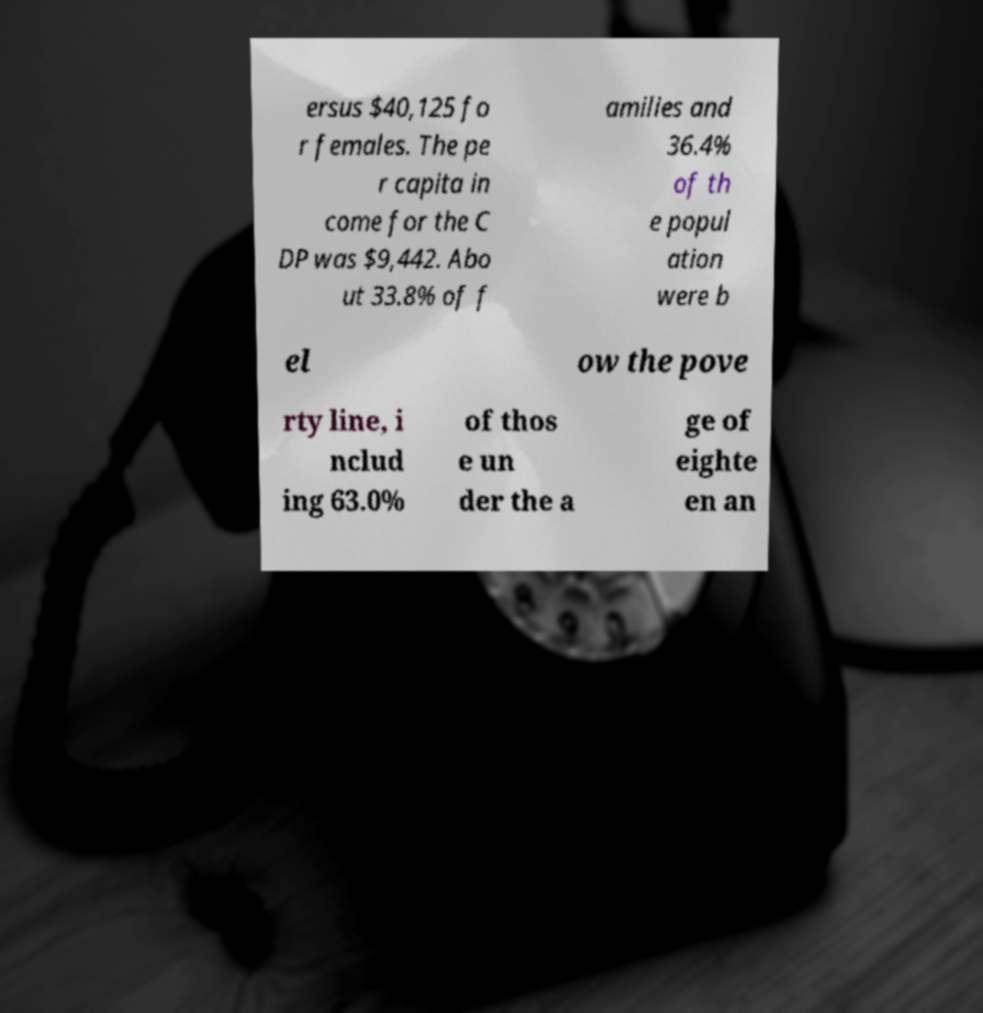I need the written content from this picture converted into text. Can you do that? ersus $40,125 fo r females. The pe r capita in come for the C DP was $9,442. Abo ut 33.8% of f amilies and 36.4% of th e popul ation were b el ow the pove rty line, i nclud ing 63.0% of thos e un der the a ge of eighte en an 